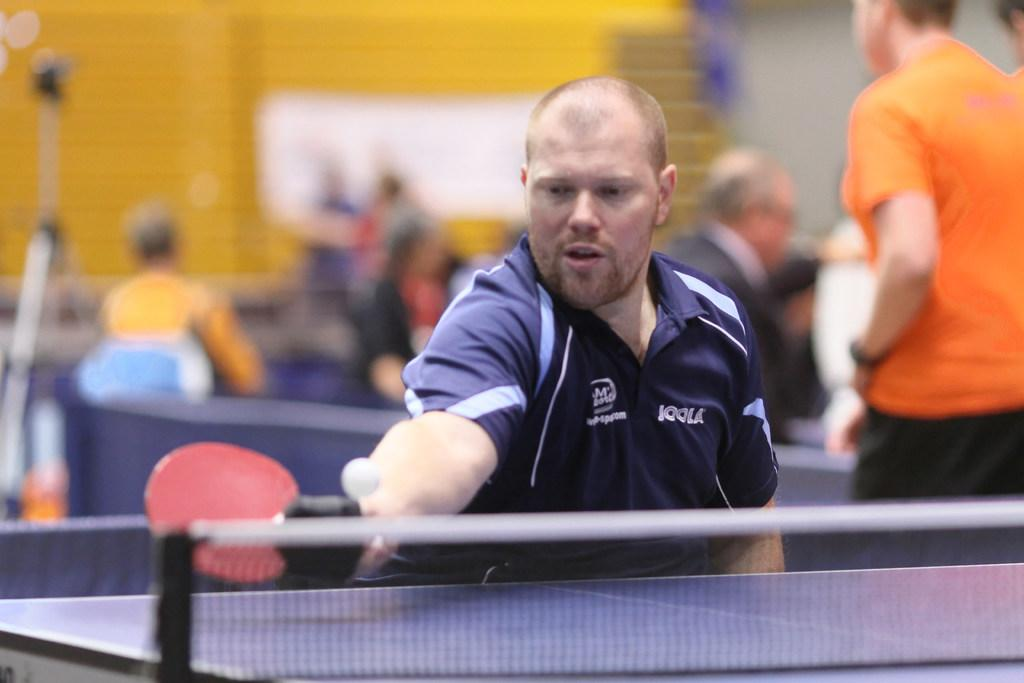What is the person in the image doing? The person is playing table tennis. What color is the shirt the person is wearing? The person is wearing a blue shirt. Are there any other people visible in the image? Yes, there are people behind the person playing table tennis. How does the person in the image wash their hands while playing table tennis? The image does not show the person washing their hands, as they are focused on playing table tennis. 